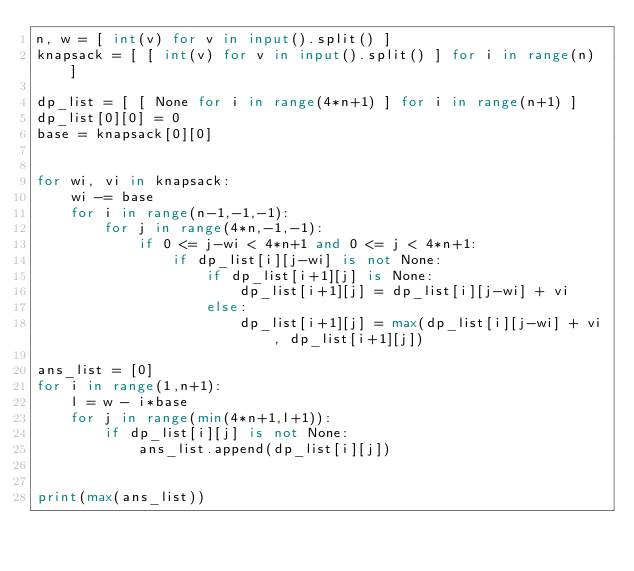<code> <loc_0><loc_0><loc_500><loc_500><_Python_>n, w = [ int(v) for v in input().split() ]
knapsack = [ [ int(v) for v in input().split() ] for i in range(n) ]

dp_list = [ [ None for i in range(4*n+1) ] for i in range(n+1) ]
dp_list[0][0] = 0
base = knapsack[0][0]


for wi, vi in knapsack:
    wi -= base
    for i in range(n-1,-1,-1):
        for j in range(4*n,-1,-1):
            if 0 <= j-wi < 4*n+1 and 0 <= j < 4*n+1:
                if dp_list[i][j-wi] is not None:
                    if dp_list[i+1][j] is None:
                        dp_list[i+1][j] = dp_list[i][j-wi] + vi
                    else:
                        dp_list[i+1][j] = max(dp_list[i][j-wi] + vi, dp_list[i+1][j])

ans_list = [0]
for i in range(1,n+1):
    l = w - i*base
    for j in range(min(4*n+1,l+1)):
        if dp_list[i][j] is not None:
            ans_list.append(dp_list[i][j])


print(max(ans_list))
</code> 